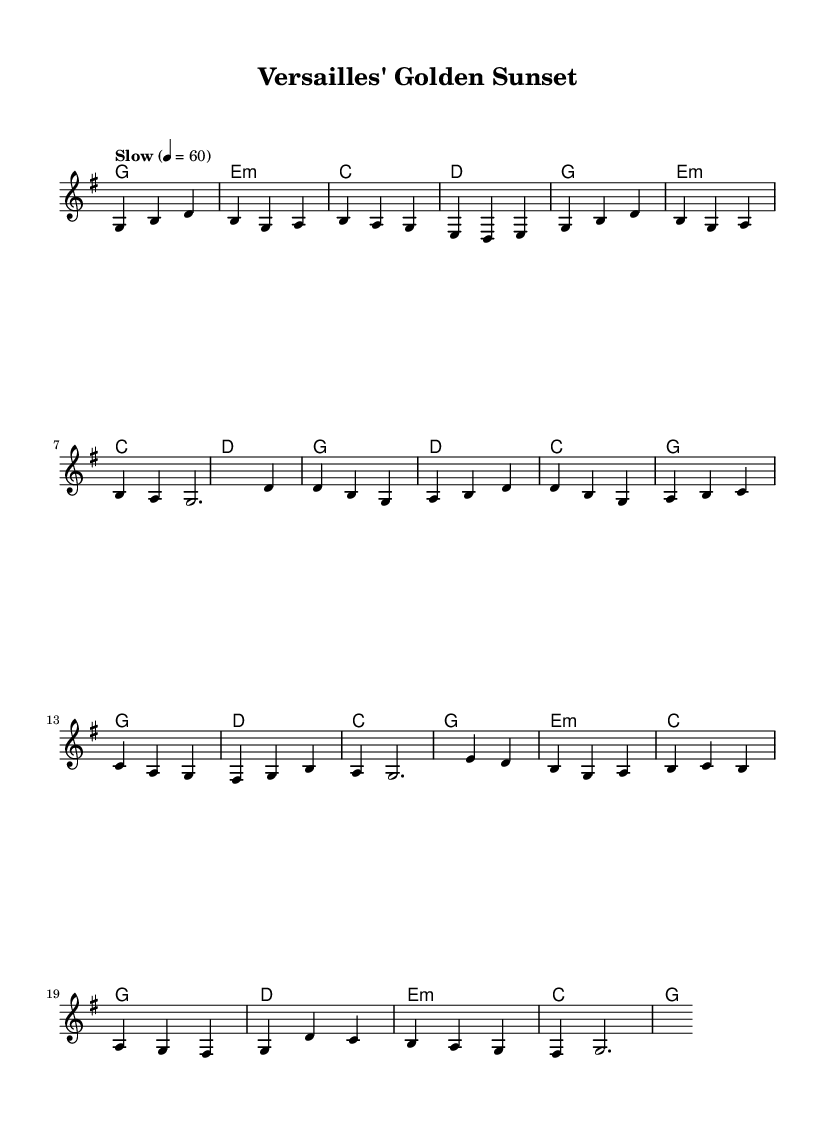What is the key signature of this music? The key signature is G major, which has one sharp (F#).
Answer: G major What is the time signature of this piece? The time signature is 3/4, indicating three beats per measure.
Answer: 3/4 What is the tempo marking provided in the score? The tempo marking is "Slow" with a metronome marking of 60 beats per minute.
Answer: Slow, 60 How many measures are in the chorus section? The chorus consists of four measures as noted in the score.
Answer: 4 What is the main theme of the lyrics? The lyrics convey a sense of nostalgia and exploration of history, particularly relating to Versailles and travel experiences.
Answer: Nostalgia and exploration Which chord is used at the beginning of the bridge? The first chord in the bridge section is E minor, which is denoted in the harmonies.
Answer: E minor How does this piece fit within the Country Rock genre? The piece combines acoustic ballad elements with a storytelling lyrical style and strong emotional imagery typical of Country Rock.
Answer: Acoustic ballad style 